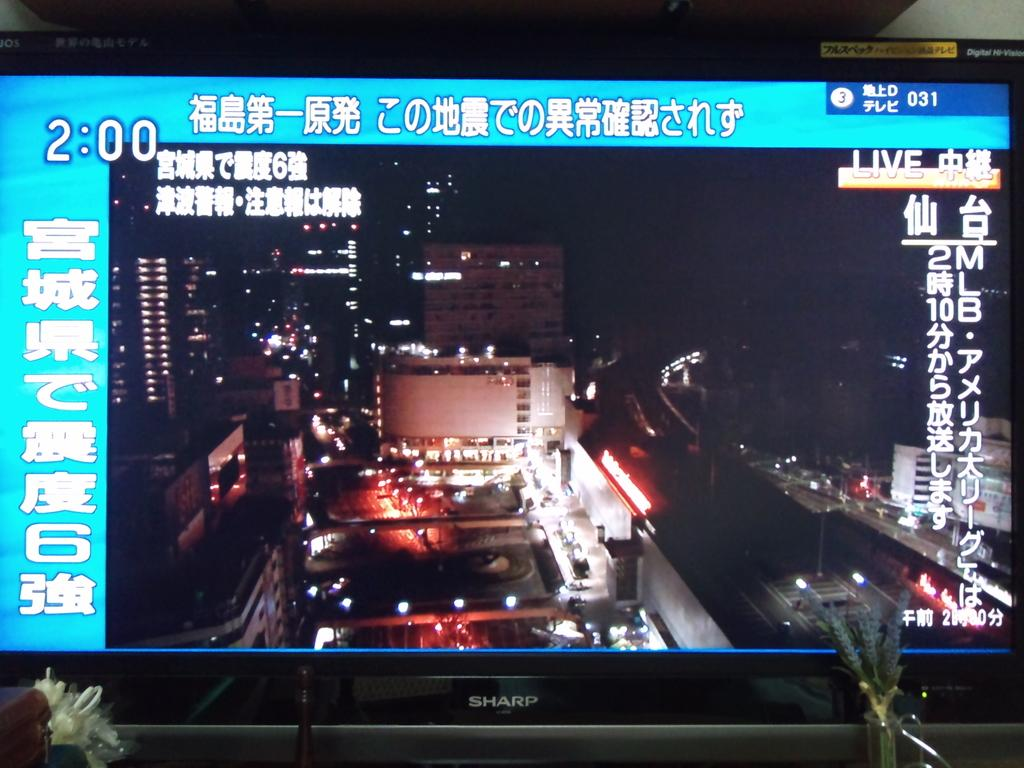Provide a one-sentence caption for the provided image. The time, 2:00, is displayed on a monitor made by Sharp. 